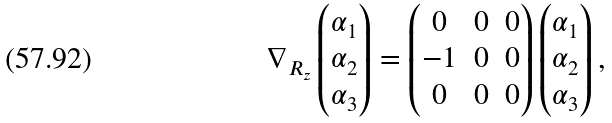Convert formula to latex. <formula><loc_0><loc_0><loc_500><loc_500>\nabla _ { R _ { z } } \left ( \begin{matrix} \alpha _ { 1 } \\ \alpha _ { 2 } \\ \alpha _ { 3 } \end{matrix} \right ) = \left ( \begin{matrix} 0 & 0 & 0 \\ - 1 & 0 & 0 \\ 0 & 0 & 0 \end{matrix} \right ) \left ( \begin{matrix} \alpha _ { 1 } \\ \alpha _ { 2 } \\ \alpha _ { 3 } \end{matrix} \right ) ,</formula> 